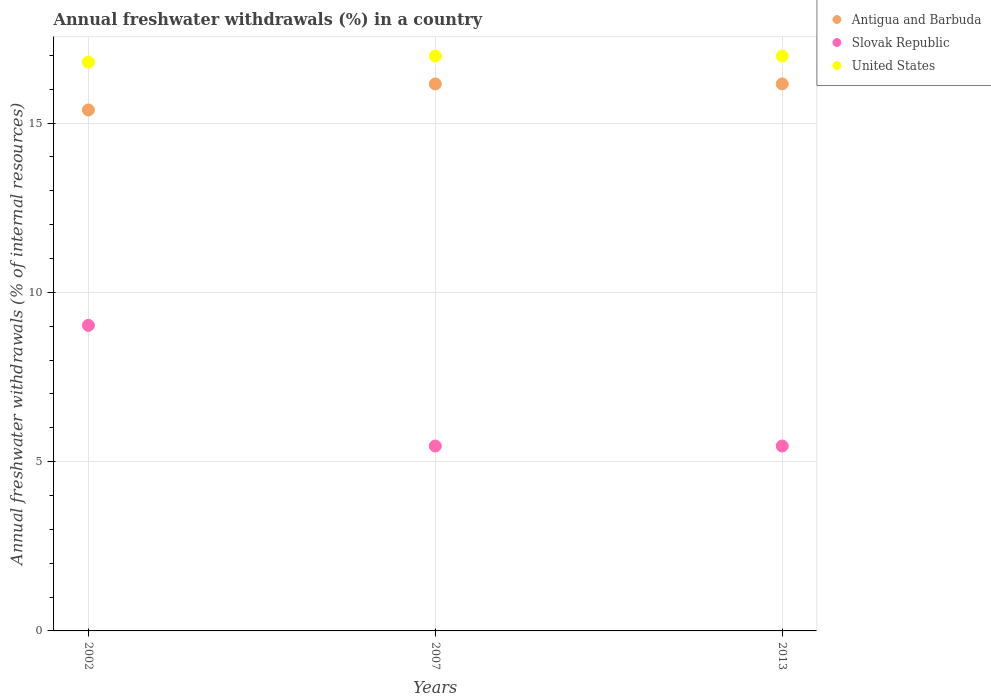Is the number of dotlines equal to the number of legend labels?
Provide a short and direct response. Yes. What is the percentage of annual freshwater withdrawals in United States in 2002?
Give a very brief answer. 16.8. Across all years, what is the maximum percentage of annual freshwater withdrawals in Slovak Republic?
Make the answer very short. 9.02. Across all years, what is the minimum percentage of annual freshwater withdrawals in United States?
Provide a short and direct response. 16.8. What is the total percentage of annual freshwater withdrawals in United States in the graph?
Give a very brief answer. 50.75. What is the difference between the percentage of annual freshwater withdrawals in Slovak Republic in 2002 and that in 2007?
Provide a short and direct response. 3.56. What is the difference between the percentage of annual freshwater withdrawals in Slovak Republic in 2002 and the percentage of annual freshwater withdrawals in United States in 2013?
Provide a short and direct response. -7.95. What is the average percentage of annual freshwater withdrawals in Slovak Republic per year?
Keep it short and to the point. 6.65. In the year 2013, what is the difference between the percentage of annual freshwater withdrawals in United States and percentage of annual freshwater withdrawals in Antigua and Barbuda?
Offer a terse response. 0.82. In how many years, is the percentage of annual freshwater withdrawals in United States greater than 2 %?
Give a very brief answer. 3. What is the ratio of the percentage of annual freshwater withdrawals in Antigua and Barbuda in 2002 to that in 2013?
Your response must be concise. 0.95. Is the percentage of annual freshwater withdrawals in United States in 2002 less than that in 2007?
Offer a terse response. Yes. Is the difference between the percentage of annual freshwater withdrawals in United States in 2002 and 2013 greater than the difference between the percentage of annual freshwater withdrawals in Antigua and Barbuda in 2002 and 2013?
Make the answer very short. Yes. What is the difference between the highest and the lowest percentage of annual freshwater withdrawals in Slovak Republic?
Keep it short and to the point. 3.56. In how many years, is the percentage of annual freshwater withdrawals in Antigua and Barbuda greater than the average percentage of annual freshwater withdrawals in Antigua and Barbuda taken over all years?
Provide a succinct answer. 2. Is it the case that in every year, the sum of the percentage of annual freshwater withdrawals in Slovak Republic and percentage of annual freshwater withdrawals in Antigua and Barbuda  is greater than the percentage of annual freshwater withdrawals in United States?
Keep it short and to the point. Yes. Does the percentage of annual freshwater withdrawals in Antigua and Barbuda monotonically increase over the years?
Your answer should be very brief. No. How many years are there in the graph?
Your answer should be compact. 3. What is the difference between two consecutive major ticks on the Y-axis?
Offer a terse response. 5. Are the values on the major ticks of Y-axis written in scientific E-notation?
Offer a terse response. No. Does the graph contain any zero values?
Offer a very short reply. No. Does the graph contain grids?
Keep it short and to the point. Yes. Where does the legend appear in the graph?
Keep it short and to the point. Top right. How many legend labels are there?
Your answer should be very brief. 3. What is the title of the graph?
Your answer should be very brief. Annual freshwater withdrawals (%) in a country. Does "Bhutan" appear as one of the legend labels in the graph?
Provide a short and direct response. No. What is the label or title of the X-axis?
Your answer should be very brief. Years. What is the label or title of the Y-axis?
Your answer should be compact. Annual freshwater withdrawals (% of internal resources). What is the Annual freshwater withdrawals (% of internal resources) in Antigua and Barbuda in 2002?
Provide a short and direct response. 15.38. What is the Annual freshwater withdrawals (% of internal resources) of Slovak Republic in 2002?
Your answer should be compact. 9.02. What is the Annual freshwater withdrawals (% of internal resources) in United States in 2002?
Keep it short and to the point. 16.8. What is the Annual freshwater withdrawals (% of internal resources) of Antigua and Barbuda in 2007?
Your answer should be compact. 16.15. What is the Annual freshwater withdrawals (% of internal resources) of Slovak Republic in 2007?
Provide a succinct answer. 5.46. What is the Annual freshwater withdrawals (% of internal resources) of United States in 2007?
Keep it short and to the point. 16.98. What is the Annual freshwater withdrawals (% of internal resources) of Antigua and Barbuda in 2013?
Offer a very short reply. 16.15. What is the Annual freshwater withdrawals (% of internal resources) of Slovak Republic in 2013?
Your answer should be very brief. 5.46. What is the Annual freshwater withdrawals (% of internal resources) of United States in 2013?
Make the answer very short. 16.98. Across all years, what is the maximum Annual freshwater withdrawals (% of internal resources) of Antigua and Barbuda?
Your answer should be very brief. 16.15. Across all years, what is the maximum Annual freshwater withdrawals (% of internal resources) of Slovak Republic?
Your response must be concise. 9.02. Across all years, what is the maximum Annual freshwater withdrawals (% of internal resources) in United States?
Keep it short and to the point. 16.98. Across all years, what is the minimum Annual freshwater withdrawals (% of internal resources) of Antigua and Barbuda?
Give a very brief answer. 15.38. Across all years, what is the minimum Annual freshwater withdrawals (% of internal resources) in Slovak Republic?
Your response must be concise. 5.46. Across all years, what is the minimum Annual freshwater withdrawals (% of internal resources) in United States?
Make the answer very short. 16.8. What is the total Annual freshwater withdrawals (% of internal resources) of Antigua and Barbuda in the graph?
Give a very brief answer. 47.69. What is the total Annual freshwater withdrawals (% of internal resources) in Slovak Republic in the graph?
Provide a short and direct response. 19.94. What is the total Annual freshwater withdrawals (% of internal resources) in United States in the graph?
Keep it short and to the point. 50.75. What is the difference between the Annual freshwater withdrawals (% of internal resources) in Antigua and Barbuda in 2002 and that in 2007?
Give a very brief answer. -0.77. What is the difference between the Annual freshwater withdrawals (% of internal resources) in Slovak Republic in 2002 and that in 2007?
Your answer should be very brief. 3.56. What is the difference between the Annual freshwater withdrawals (% of internal resources) of United States in 2002 and that in 2007?
Your answer should be compact. -0.18. What is the difference between the Annual freshwater withdrawals (% of internal resources) in Antigua and Barbuda in 2002 and that in 2013?
Provide a succinct answer. -0.77. What is the difference between the Annual freshwater withdrawals (% of internal resources) of Slovak Republic in 2002 and that in 2013?
Offer a terse response. 3.56. What is the difference between the Annual freshwater withdrawals (% of internal resources) of United States in 2002 and that in 2013?
Keep it short and to the point. -0.18. What is the difference between the Annual freshwater withdrawals (% of internal resources) of Antigua and Barbuda in 2007 and that in 2013?
Make the answer very short. 0. What is the difference between the Annual freshwater withdrawals (% of internal resources) in Slovak Republic in 2007 and that in 2013?
Offer a very short reply. 0. What is the difference between the Annual freshwater withdrawals (% of internal resources) of United States in 2007 and that in 2013?
Make the answer very short. 0. What is the difference between the Annual freshwater withdrawals (% of internal resources) in Antigua and Barbuda in 2002 and the Annual freshwater withdrawals (% of internal resources) in Slovak Republic in 2007?
Keep it short and to the point. 9.92. What is the difference between the Annual freshwater withdrawals (% of internal resources) of Antigua and Barbuda in 2002 and the Annual freshwater withdrawals (% of internal resources) of United States in 2007?
Your answer should be compact. -1.59. What is the difference between the Annual freshwater withdrawals (% of internal resources) of Slovak Republic in 2002 and the Annual freshwater withdrawals (% of internal resources) of United States in 2007?
Provide a succinct answer. -7.95. What is the difference between the Annual freshwater withdrawals (% of internal resources) in Antigua and Barbuda in 2002 and the Annual freshwater withdrawals (% of internal resources) in Slovak Republic in 2013?
Ensure brevity in your answer.  9.92. What is the difference between the Annual freshwater withdrawals (% of internal resources) of Antigua and Barbuda in 2002 and the Annual freshwater withdrawals (% of internal resources) of United States in 2013?
Make the answer very short. -1.59. What is the difference between the Annual freshwater withdrawals (% of internal resources) of Slovak Republic in 2002 and the Annual freshwater withdrawals (% of internal resources) of United States in 2013?
Offer a terse response. -7.95. What is the difference between the Annual freshwater withdrawals (% of internal resources) in Antigua and Barbuda in 2007 and the Annual freshwater withdrawals (% of internal resources) in Slovak Republic in 2013?
Provide a short and direct response. 10.69. What is the difference between the Annual freshwater withdrawals (% of internal resources) in Antigua and Barbuda in 2007 and the Annual freshwater withdrawals (% of internal resources) in United States in 2013?
Your answer should be very brief. -0.82. What is the difference between the Annual freshwater withdrawals (% of internal resources) in Slovak Republic in 2007 and the Annual freshwater withdrawals (% of internal resources) in United States in 2013?
Keep it short and to the point. -11.52. What is the average Annual freshwater withdrawals (% of internal resources) of Antigua and Barbuda per year?
Provide a succinct answer. 15.9. What is the average Annual freshwater withdrawals (% of internal resources) in Slovak Republic per year?
Your answer should be very brief. 6.65. What is the average Annual freshwater withdrawals (% of internal resources) in United States per year?
Keep it short and to the point. 16.92. In the year 2002, what is the difference between the Annual freshwater withdrawals (% of internal resources) of Antigua and Barbuda and Annual freshwater withdrawals (% of internal resources) of Slovak Republic?
Your answer should be compact. 6.36. In the year 2002, what is the difference between the Annual freshwater withdrawals (% of internal resources) of Antigua and Barbuda and Annual freshwater withdrawals (% of internal resources) of United States?
Ensure brevity in your answer.  -1.41. In the year 2002, what is the difference between the Annual freshwater withdrawals (% of internal resources) in Slovak Republic and Annual freshwater withdrawals (% of internal resources) in United States?
Offer a very short reply. -7.78. In the year 2007, what is the difference between the Annual freshwater withdrawals (% of internal resources) of Antigua and Barbuda and Annual freshwater withdrawals (% of internal resources) of Slovak Republic?
Ensure brevity in your answer.  10.69. In the year 2007, what is the difference between the Annual freshwater withdrawals (% of internal resources) in Antigua and Barbuda and Annual freshwater withdrawals (% of internal resources) in United States?
Offer a terse response. -0.82. In the year 2007, what is the difference between the Annual freshwater withdrawals (% of internal resources) of Slovak Republic and Annual freshwater withdrawals (% of internal resources) of United States?
Provide a short and direct response. -11.52. In the year 2013, what is the difference between the Annual freshwater withdrawals (% of internal resources) in Antigua and Barbuda and Annual freshwater withdrawals (% of internal resources) in Slovak Republic?
Offer a very short reply. 10.69. In the year 2013, what is the difference between the Annual freshwater withdrawals (% of internal resources) of Antigua and Barbuda and Annual freshwater withdrawals (% of internal resources) of United States?
Ensure brevity in your answer.  -0.82. In the year 2013, what is the difference between the Annual freshwater withdrawals (% of internal resources) of Slovak Republic and Annual freshwater withdrawals (% of internal resources) of United States?
Make the answer very short. -11.52. What is the ratio of the Annual freshwater withdrawals (% of internal resources) in Slovak Republic in 2002 to that in 2007?
Make the answer very short. 1.65. What is the ratio of the Annual freshwater withdrawals (% of internal resources) of Slovak Republic in 2002 to that in 2013?
Provide a short and direct response. 1.65. What is the ratio of the Annual freshwater withdrawals (% of internal resources) of Antigua and Barbuda in 2007 to that in 2013?
Make the answer very short. 1. What is the ratio of the Annual freshwater withdrawals (% of internal resources) in Slovak Republic in 2007 to that in 2013?
Offer a very short reply. 1. What is the ratio of the Annual freshwater withdrawals (% of internal resources) in United States in 2007 to that in 2013?
Ensure brevity in your answer.  1. What is the difference between the highest and the second highest Annual freshwater withdrawals (% of internal resources) of Antigua and Barbuda?
Offer a terse response. 0. What is the difference between the highest and the second highest Annual freshwater withdrawals (% of internal resources) in Slovak Republic?
Your answer should be very brief. 3.56. What is the difference between the highest and the lowest Annual freshwater withdrawals (% of internal resources) of Antigua and Barbuda?
Offer a terse response. 0.77. What is the difference between the highest and the lowest Annual freshwater withdrawals (% of internal resources) of Slovak Republic?
Provide a short and direct response. 3.56. What is the difference between the highest and the lowest Annual freshwater withdrawals (% of internal resources) in United States?
Your response must be concise. 0.18. 